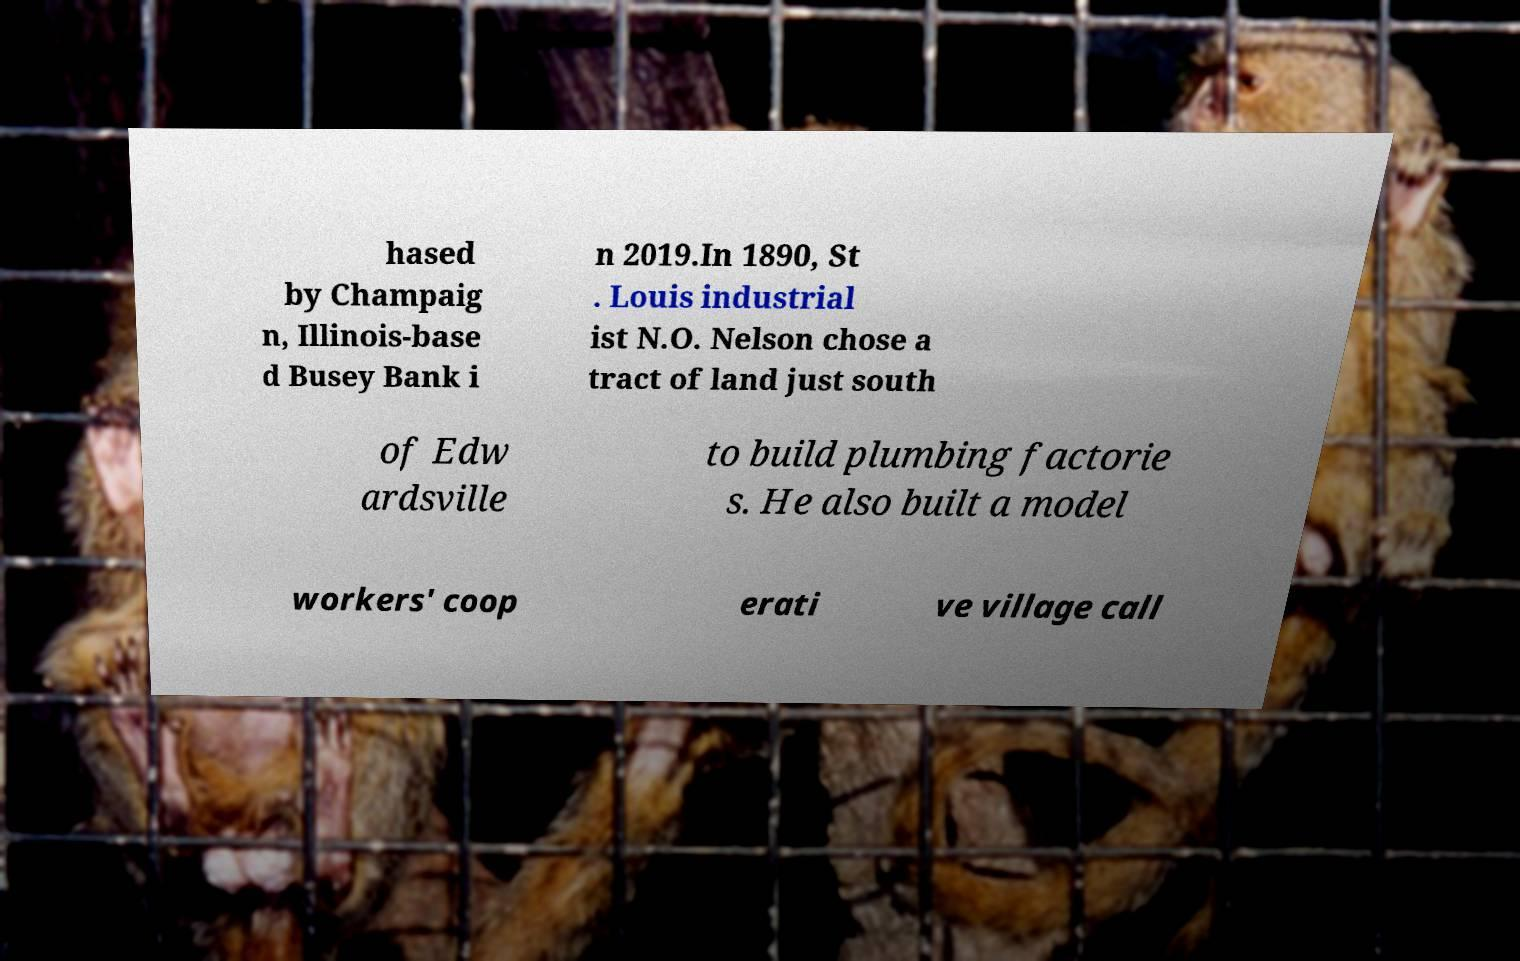I need the written content from this picture converted into text. Can you do that? hased by Champaig n, Illinois-base d Busey Bank i n 2019.In 1890, St . Louis industrial ist N.O. Nelson chose a tract of land just south of Edw ardsville to build plumbing factorie s. He also built a model workers' coop erati ve village call 